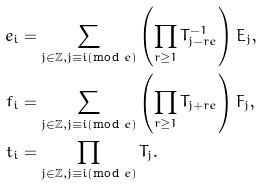<formula> <loc_0><loc_0><loc_500><loc_500>e _ { i } & = \sum _ { j \in \mathbb { Z } , j \equiv i ( \text {mod } e ) } \left ( \prod _ { r \geq 1 } T _ { j - r e } ^ { - 1 } \right ) E _ { j } , \\ f _ { i } & = \sum _ { j \in \mathbb { Z } , j \equiv i ( \text {mod } e ) } \left ( \prod _ { r \geq 1 } T _ { j + r e } \right ) F _ { j } , \\ t _ { i } & = \prod _ { j \in \mathbb { Z } , j \equiv i ( \text {mod } e ) } T _ { j } .</formula> 